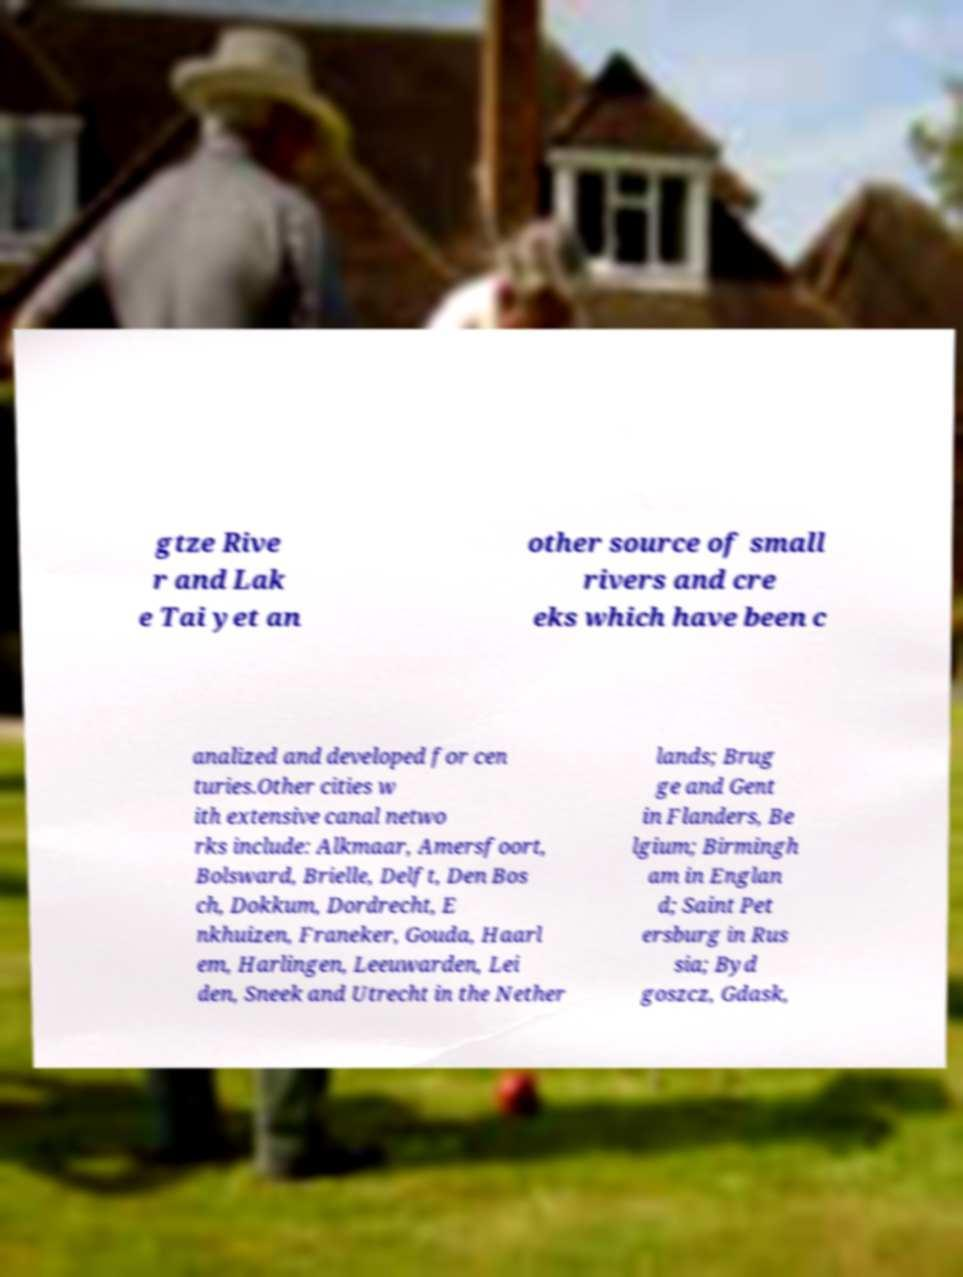Can you accurately transcribe the text from the provided image for me? gtze Rive r and Lak e Tai yet an other source of small rivers and cre eks which have been c analized and developed for cen turies.Other cities w ith extensive canal netwo rks include: Alkmaar, Amersfoort, Bolsward, Brielle, Delft, Den Bos ch, Dokkum, Dordrecht, E nkhuizen, Franeker, Gouda, Haarl em, Harlingen, Leeuwarden, Lei den, Sneek and Utrecht in the Nether lands; Brug ge and Gent in Flanders, Be lgium; Birmingh am in Englan d; Saint Pet ersburg in Rus sia; Byd goszcz, Gdask, 